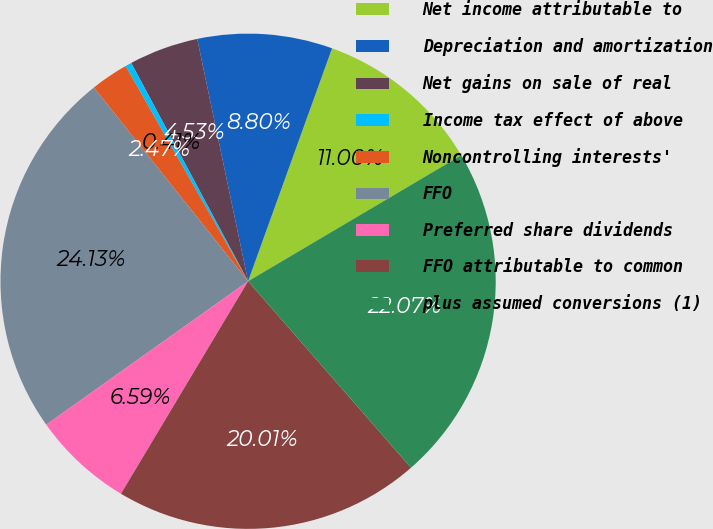<chart> <loc_0><loc_0><loc_500><loc_500><pie_chart><fcel>Net income attributable to<fcel>Depreciation and amortization<fcel>Net gains on sale of real<fcel>Income tax effect of above<fcel>Noncontrolling interests'<fcel>FFO<fcel>Preferred share dividends<fcel>FFO attributable to common<fcel>plus assumed conversions (1)<nl><fcel>11.0%<fcel>8.8%<fcel>4.53%<fcel>0.41%<fcel>2.47%<fcel>24.13%<fcel>6.59%<fcel>20.01%<fcel>22.07%<nl></chart> 